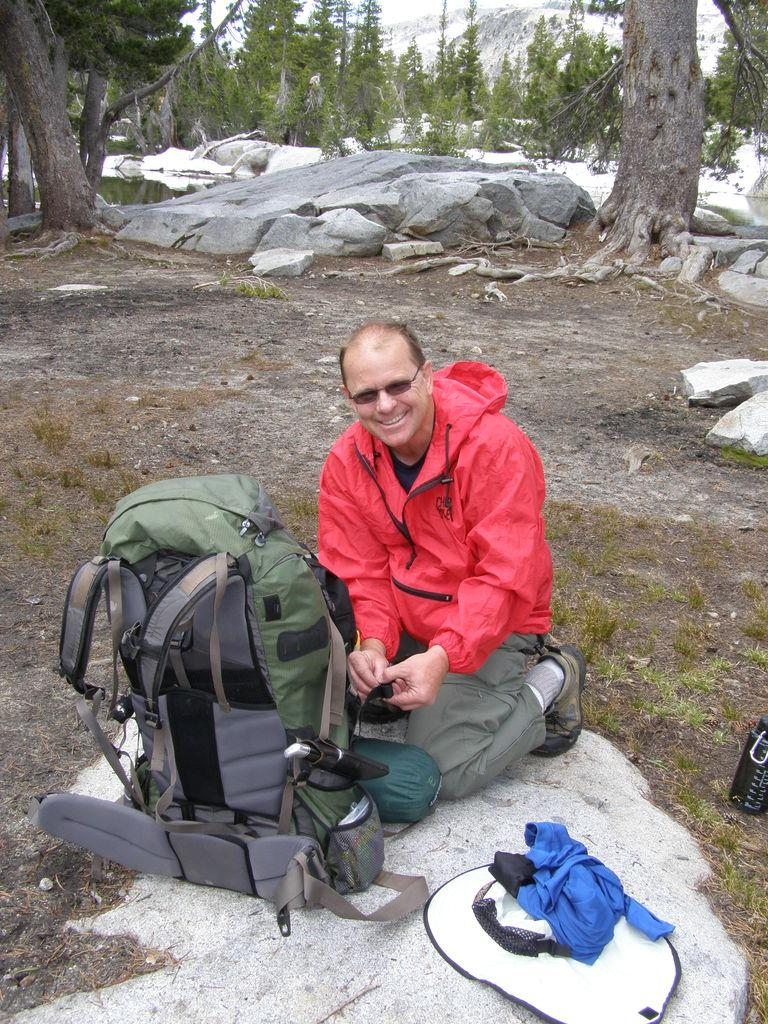Who is present in the image? There is a man in the image. What is the man doing in the image? The man is sitting. What is the man wearing in the image? The man is wearing a red jacket. What object is in front of the man in the image? There is a travel backpack in front of the man. What can be seen in the background of the image? There are trees visible in the background of the image. What type of twig is the man holding in the image? There is no twig present in the image; the man is not holding anything. How does the man's income affect the image? The man's income is not mentioned in the image or the provided facts, so it cannot be determined how it might affect the image. 